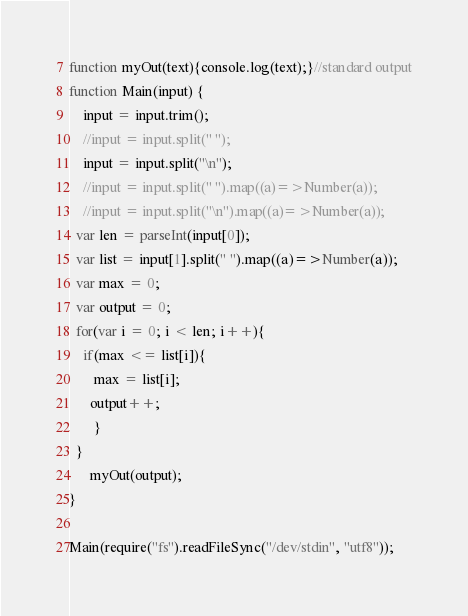<code> <loc_0><loc_0><loc_500><loc_500><_JavaScript_>function myOut(text){console.log(text);}//standard output
function Main(input) {
	input = input.trim();
	//input = input.split(" ");
	input = input.split("\n");
	//input = input.split(" ").map((a)=>Number(a));
	//input = input.split("\n").map((a)=>Number(a));
  var len = parseInt(input[0]);
  var list = input[1].split(" ").map((a)=>Number(a));
  var max = 0;
  var output = 0;
  for(var i = 0; i < len; i++){
    if(max <= list[i]){
       max = list[i];
      output++;
       }
  }
      myOut(output);
}

Main(require("fs").readFileSync("/dev/stdin", "utf8"));
</code> 